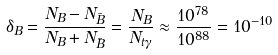Convert formula to latex. <formula><loc_0><loc_0><loc_500><loc_500>\delta _ { B } = \frac { N _ { B } - N _ { \bar { B } } } { N _ { B } + N _ { \bar { B } } } = \frac { N _ { B } } { N _ { t \gamma } } \approx \frac { 1 0 ^ { 7 8 } } { 1 0 ^ { 8 8 } } = 1 0 ^ { - 1 0 }</formula> 